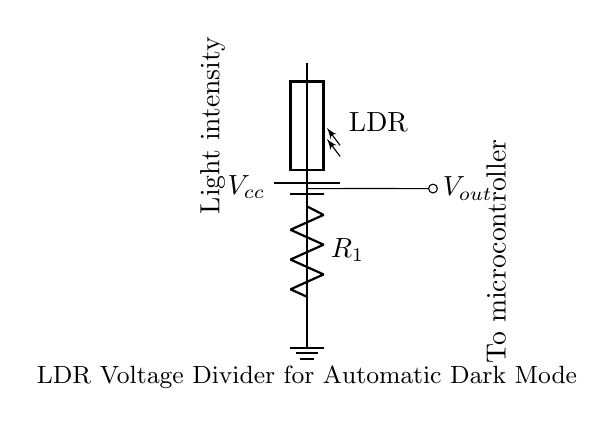What is the power supply voltage in this circuit? The power supply voltage is marked as Vcc on the battery component in the diagram.
Answer: Vcc What component is labelled as LDR? The component that is being identified as LDR in the diagram is specifically the photoresistor connected to the circuit, responsible for varying resistance based on light intensity.
Answer: LDR What is the purpose of the fixed resistor in this circuit? The fixed resistor, labelled as R1, is part of the voltage divider configuration, helping to set the output voltage based on the LDR's resistance in relation to the light intensity.
Answer: Voltage division How is the output voltage taken from the circuit? The output voltage, labelled as Vout, is taken from the node between the LDR and the fixed resistor, where the voltage will vary according to the light intensity sensed by the LDR.
Answer: From the node What happens to the output voltage when light intensity decreases? When light intensity decreases, the resistance of the LDR increases, causing the output voltage to increase due to a greater voltage drop across the LDR in the voltage divider setup.
Answer: Output voltage increases Explain the role of the microcontroller in this circuit. The microcontroller receives the output voltage (Vout) from the voltage divider, allowing it to determine ambient light levels and adjust the web application's mode (such as switching to dark mode) based on the light detected.
Answer: Control dark mode 